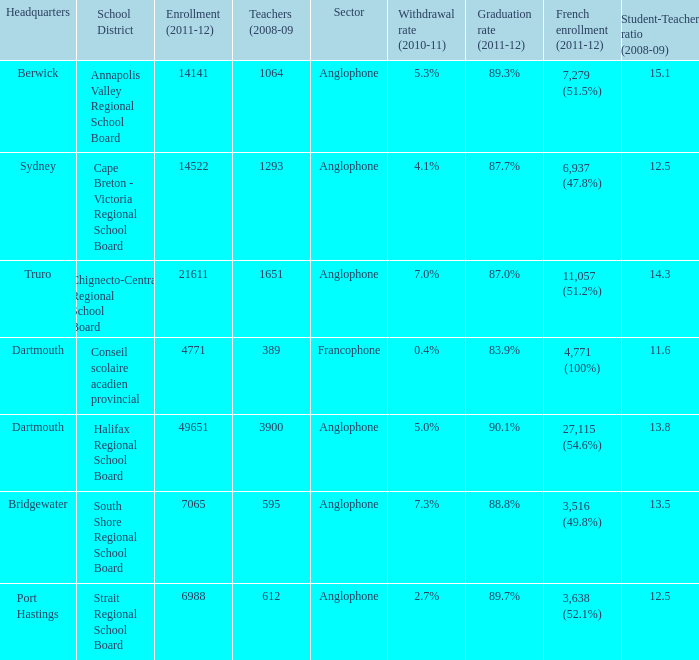What is their withdrawal rate for the school district with headquarters located in Truro? 7.0%. Help me parse the entirety of this table. {'header': ['Headquarters', 'School District', 'Enrollment (2011-12)', 'Teachers (2008-09', 'Sector', 'Withdrawal rate (2010-11)', 'Graduation rate (2011-12)', 'French enrollment (2011-12)', 'Student-Teacher ratio (2008-09)'], 'rows': [['Berwick', 'Annapolis Valley Regional School Board', '14141', '1064', 'Anglophone', '5.3%', '89.3%', '7,279 (51.5%)', '15.1'], ['Sydney', 'Cape Breton - Victoria Regional School Board', '14522', '1293', 'Anglophone', '4.1%', '87.7%', '6,937 (47.8%)', '12.5'], ['Truro', 'Chignecto-Central Regional School Board', '21611', '1651', 'Anglophone', '7.0%', '87.0%', '11,057 (51.2%)', '14.3'], ['Dartmouth', 'Conseil scolaire acadien provincial', '4771', '389', 'Francophone', '0.4%', '83.9%', '4,771 (100%)', '11.6'], ['Dartmouth', 'Halifax Regional School Board', '49651', '3900', 'Anglophone', '5.0%', '90.1%', '27,115 (54.6%)', '13.8'], ['Bridgewater', 'South Shore Regional School Board', '7065', '595', 'Anglophone', '7.3%', '88.8%', '3,516 (49.8%)', '13.5'], ['Port Hastings', 'Strait Regional School Board', '6988', '612', 'Anglophone', '2.7%', '89.7%', '3,638 (52.1%)', '12.5']]} 